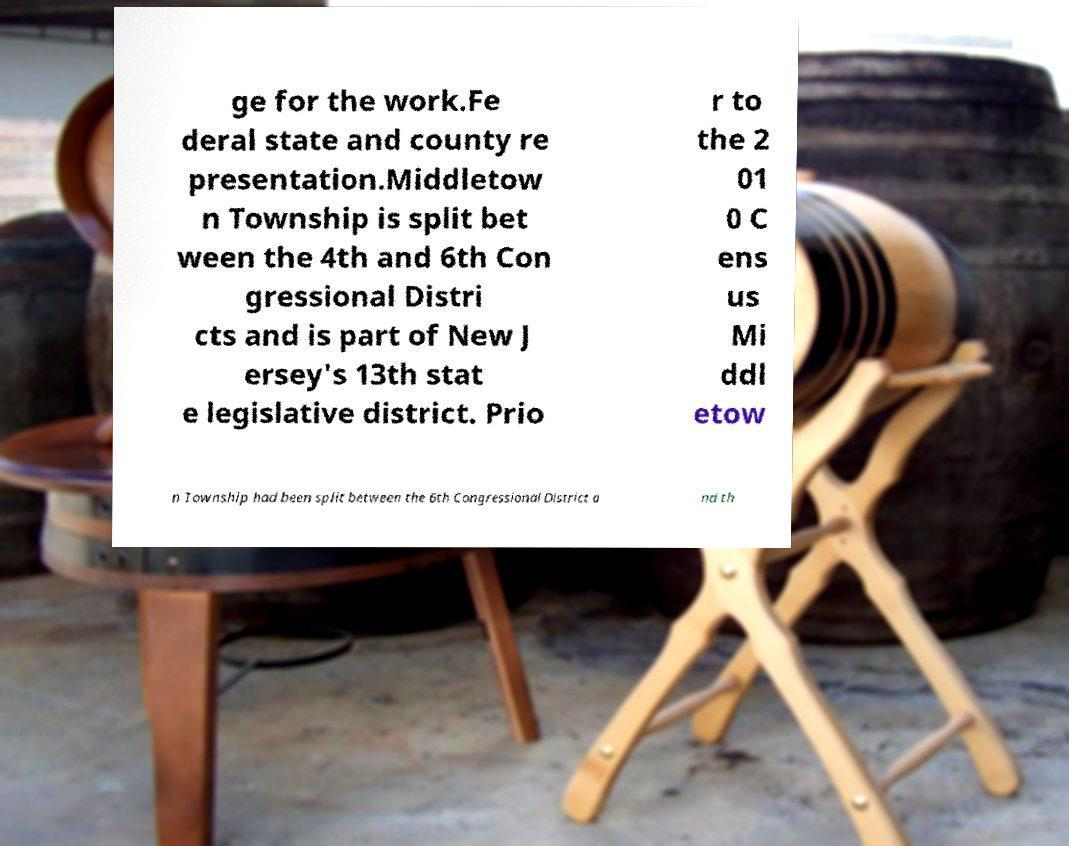Please read and relay the text visible in this image. What does it say? ge for the work.Fe deral state and county re presentation.Middletow n Township is split bet ween the 4th and 6th Con gressional Distri cts and is part of New J ersey's 13th stat e legislative district. Prio r to the 2 01 0 C ens us Mi ddl etow n Township had been split between the 6th Congressional District a nd th 